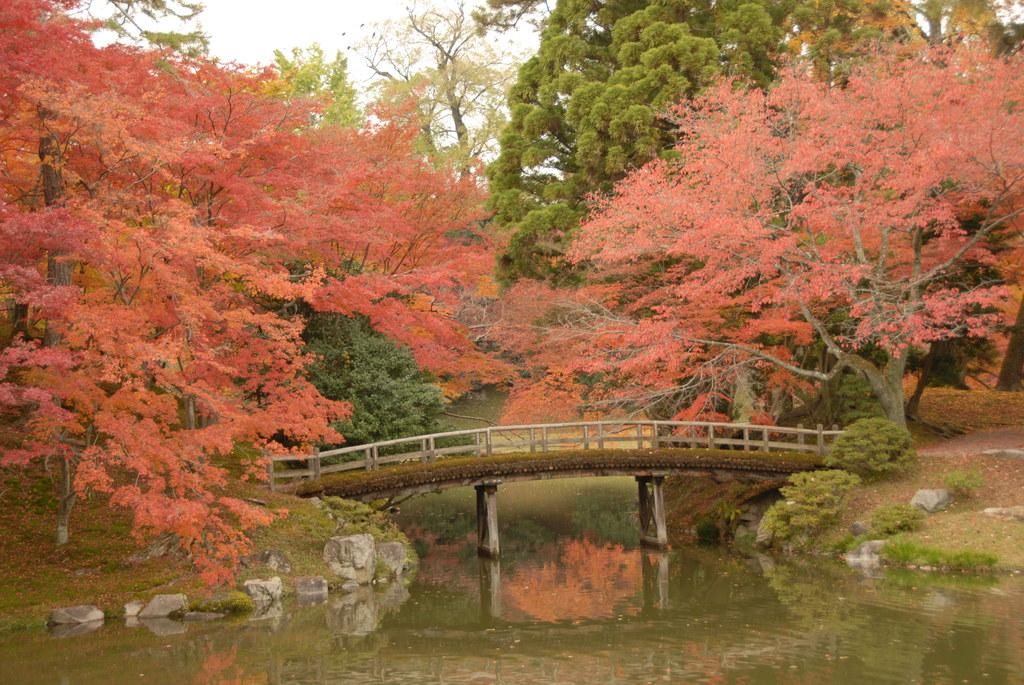What type of natural vegetation is present in the image? There are trees and plants in the image. What other natural elements can be seen in the image? There are rocks and water visible in the image. What type of man-made structure is present in the image? There is a bridge in the image. What is visible in the sky in the image? The sky is visible in the image. What type of hobbies are the trees participating in within the image? Trees do not participate in hobbies, as they are inanimate objects. Can you tell me how many carriages are present in the image? There are no carriages present in the image. 